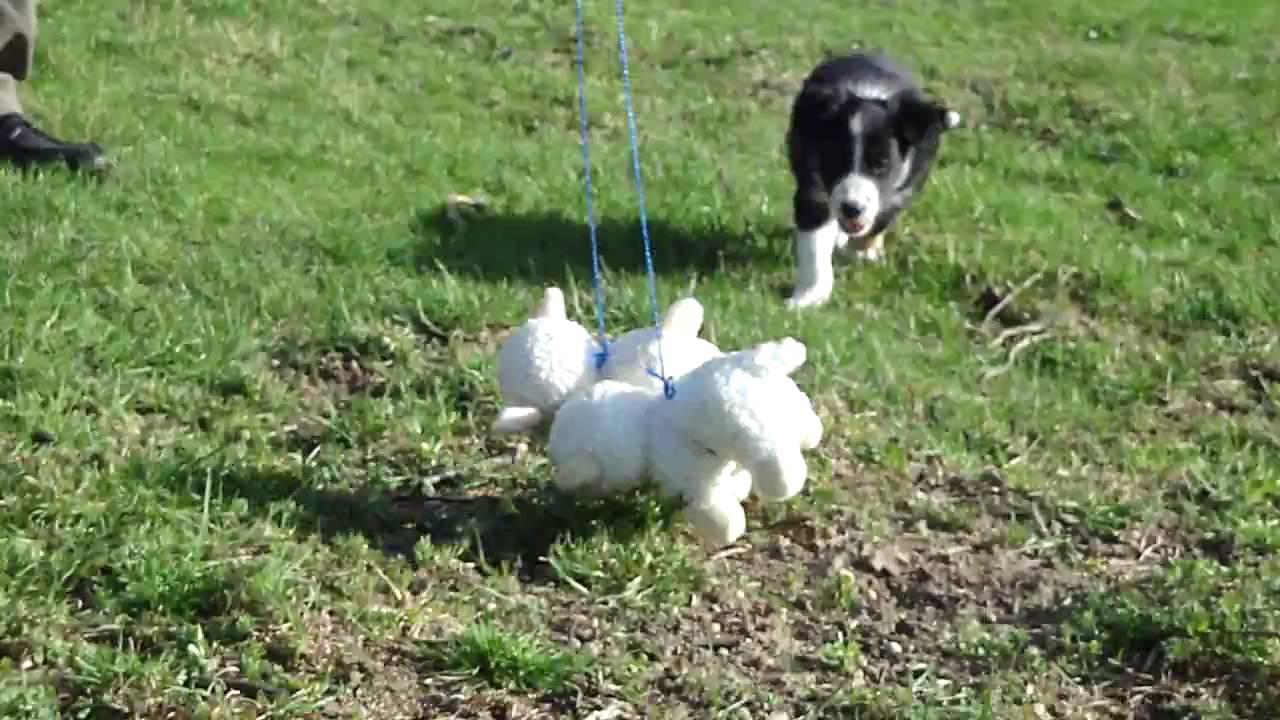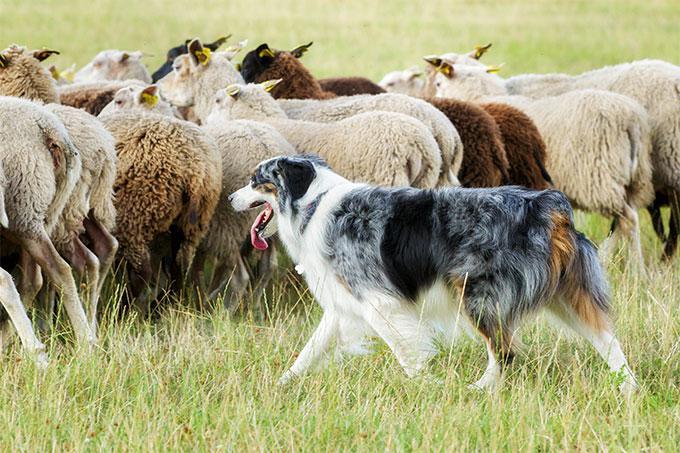The first image is the image on the left, the second image is the image on the right. Evaluate the accuracy of this statement regarding the images: "One of the images shows exactly one dog with one sheep.". Is it true? Answer yes or no. No. 